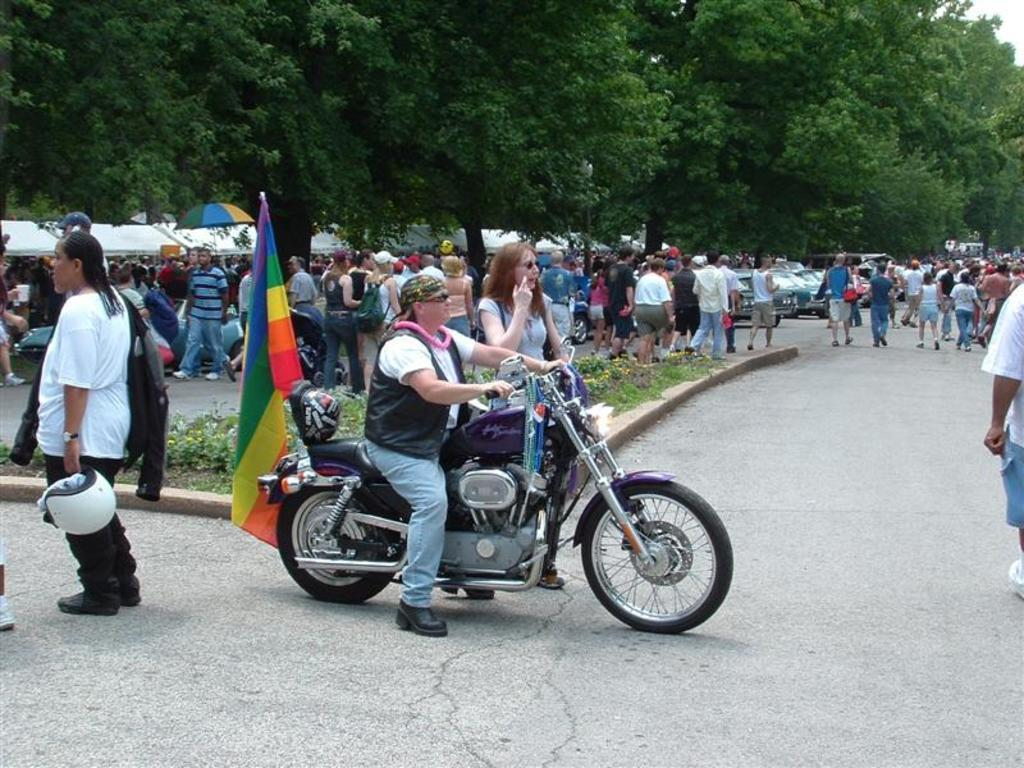How many people are in the image? There is a group of people in the image. What are the people in the image doing? The people are walking on a road. Can you describe the person on the bike? One person is sitting on a bike and holding a helmet. What can be seen in the background of the image? There are trees, an umbrella, and flags visible in the background. What type of comb is the person using to read books in the image? There is no comb or books present in the image; the person is sitting on a bike and holding a helmet. 